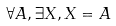Convert formula to latex. <formula><loc_0><loc_0><loc_500><loc_500>\forall A , \exists X , X = A</formula> 